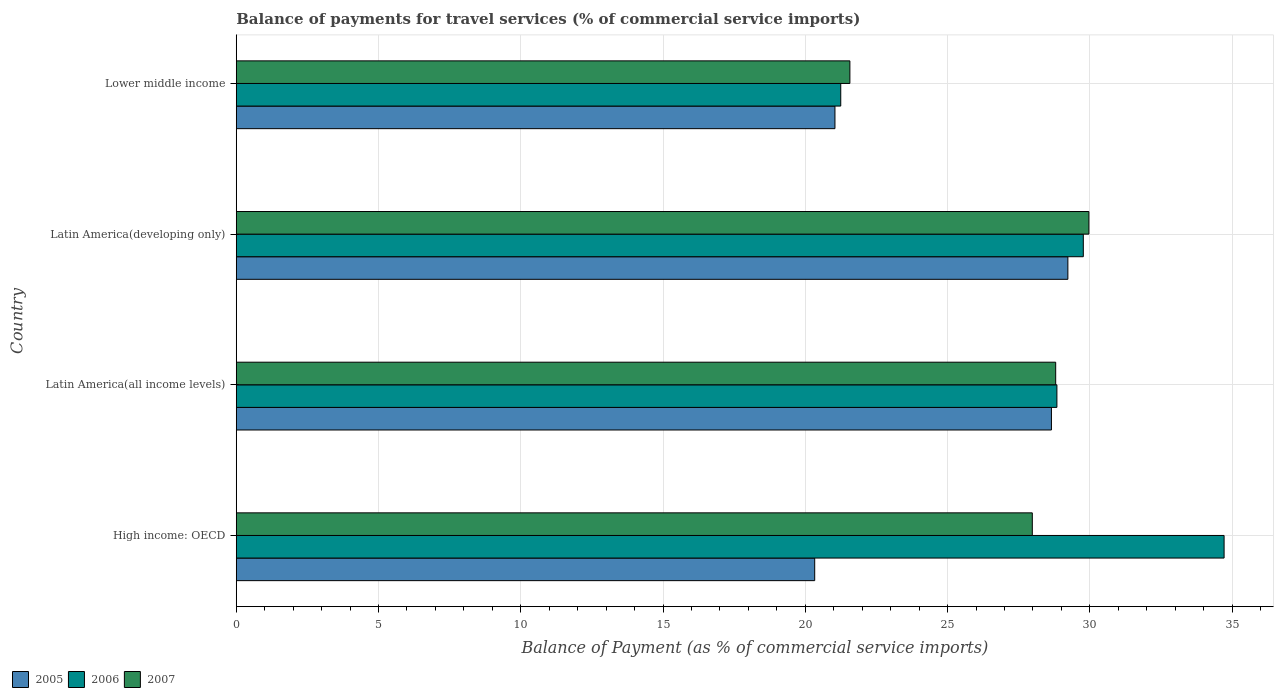Are the number of bars per tick equal to the number of legend labels?
Make the answer very short. Yes. What is the label of the 1st group of bars from the top?
Offer a very short reply. Lower middle income. What is the balance of payments for travel services in 2007 in Latin America(all income levels)?
Offer a terse response. 28.8. Across all countries, what is the maximum balance of payments for travel services in 2006?
Ensure brevity in your answer.  34.72. Across all countries, what is the minimum balance of payments for travel services in 2007?
Your response must be concise. 21.57. In which country was the balance of payments for travel services in 2006 maximum?
Make the answer very short. High income: OECD. In which country was the balance of payments for travel services in 2006 minimum?
Provide a short and direct response. Lower middle income. What is the total balance of payments for travel services in 2005 in the graph?
Your response must be concise. 99.25. What is the difference between the balance of payments for travel services in 2005 in Latin America(all income levels) and that in Lower middle income?
Offer a very short reply. 7.61. What is the difference between the balance of payments for travel services in 2005 in Lower middle income and the balance of payments for travel services in 2007 in High income: OECD?
Provide a short and direct response. -6.94. What is the average balance of payments for travel services in 2006 per country?
Your answer should be compact. 28.65. What is the difference between the balance of payments for travel services in 2006 and balance of payments for travel services in 2005 in Latin America(developing only)?
Provide a short and direct response. 0.54. In how many countries, is the balance of payments for travel services in 2006 greater than 29 %?
Give a very brief answer. 2. What is the ratio of the balance of payments for travel services in 2005 in Latin America(all income levels) to that in Lower middle income?
Offer a very short reply. 1.36. Is the difference between the balance of payments for travel services in 2006 in High income: OECD and Latin America(all income levels) greater than the difference between the balance of payments for travel services in 2005 in High income: OECD and Latin America(all income levels)?
Offer a terse response. Yes. What is the difference between the highest and the second highest balance of payments for travel services in 2007?
Your answer should be compact. 1.17. What is the difference between the highest and the lowest balance of payments for travel services in 2005?
Keep it short and to the point. 8.9. Is the sum of the balance of payments for travel services in 2005 in Latin America(all income levels) and Latin America(developing only) greater than the maximum balance of payments for travel services in 2006 across all countries?
Provide a succinct answer. Yes. What does the 1st bar from the top in Lower middle income represents?
Your answer should be compact. 2007. Is it the case that in every country, the sum of the balance of payments for travel services in 2006 and balance of payments for travel services in 2007 is greater than the balance of payments for travel services in 2005?
Make the answer very short. Yes. How many bars are there?
Provide a short and direct response. 12. Are all the bars in the graph horizontal?
Give a very brief answer. Yes. What is the difference between two consecutive major ticks on the X-axis?
Keep it short and to the point. 5. Are the values on the major ticks of X-axis written in scientific E-notation?
Offer a terse response. No. How many legend labels are there?
Give a very brief answer. 3. What is the title of the graph?
Your response must be concise. Balance of payments for travel services (% of commercial service imports). Does "1989" appear as one of the legend labels in the graph?
Ensure brevity in your answer.  No. What is the label or title of the X-axis?
Your answer should be compact. Balance of Payment (as % of commercial service imports). What is the Balance of Payment (as % of commercial service imports) in 2005 in High income: OECD?
Your answer should be very brief. 20.33. What is the Balance of Payment (as % of commercial service imports) in 2006 in High income: OECD?
Offer a terse response. 34.72. What is the Balance of Payment (as % of commercial service imports) of 2007 in High income: OECD?
Make the answer very short. 27.98. What is the Balance of Payment (as % of commercial service imports) in 2005 in Latin America(all income levels)?
Your answer should be very brief. 28.65. What is the Balance of Payment (as % of commercial service imports) in 2006 in Latin America(all income levels)?
Your answer should be compact. 28.84. What is the Balance of Payment (as % of commercial service imports) in 2007 in Latin America(all income levels)?
Give a very brief answer. 28.8. What is the Balance of Payment (as % of commercial service imports) in 2005 in Latin America(developing only)?
Make the answer very short. 29.23. What is the Balance of Payment (as % of commercial service imports) of 2006 in Latin America(developing only)?
Your answer should be very brief. 29.77. What is the Balance of Payment (as % of commercial service imports) of 2007 in Latin America(developing only)?
Offer a terse response. 29.97. What is the Balance of Payment (as % of commercial service imports) of 2005 in Lower middle income?
Keep it short and to the point. 21.04. What is the Balance of Payment (as % of commercial service imports) of 2006 in Lower middle income?
Provide a short and direct response. 21.25. What is the Balance of Payment (as % of commercial service imports) in 2007 in Lower middle income?
Your answer should be compact. 21.57. Across all countries, what is the maximum Balance of Payment (as % of commercial service imports) in 2005?
Offer a very short reply. 29.23. Across all countries, what is the maximum Balance of Payment (as % of commercial service imports) in 2006?
Keep it short and to the point. 34.72. Across all countries, what is the maximum Balance of Payment (as % of commercial service imports) of 2007?
Your answer should be very brief. 29.97. Across all countries, what is the minimum Balance of Payment (as % of commercial service imports) of 2005?
Ensure brevity in your answer.  20.33. Across all countries, what is the minimum Balance of Payment (as % of commercial service imports) in 2006?
Offer a very short reply. 21.25. Across all countries, what is the minimum Balance of Payment (as % of commercial service imports) of 2007?
Make the answer very short. 21.57. What is the total Balance of Payment (as % of commercial service imports) of 2005 in the graph?
Give a very brief answer. 99.25. What is the total Balance of Payment (as % of commercial service imports) of 2006 in the graph?
Your response must be concise. 114.58. What is the total Balance of Payment (as % of commercial service imports) in 2007 in the graph?
Provide a succinct answer. 108.31. What is the difference between the Balance of Payment (as % of commercial service imports) in 2005 in High income: OECD and that in Latin America(all income levels)?
Offer a very short reply. -8.32. What is the difference between the Balance of Payment (as % of commercial service imports) of 2006 in High income: OECD and that in Latin America(all income levels)?
Give a very brief answer. 5.88. What is the difference between the Balance of Payment (as % of commercial service imports) of 2007 in High income: OECD and that in Latin America(all income levels)?
Offer a very short reply. -0.82. What is the difference between the Balance of Payment (as % of commercial service imports) of 2005 in High income: OECD and that in Latin America(developing only)?
Offer a very short reply. -8.9. What is the difference between the Balance of Payment (as % of commercial service imports) of 2006 in High income: OECD and that in Latin America(developing only)?
Offer a very short reply. 4.95. What is the difference between the Balance of Payment (as % of commercial service imports) of 2007 in High income: OECD and that in Latin America(developing only)?
Keep it short and to the point. -1.99. What is the difference between the Balance of Payment (as % of commercial service imports) of 2005 in High income: OECD and that in Lower middle income?
Provide a short and direct response. -0.71. What is the difference between the Balance of Payment (as % of commercial service imports) of 2006 in High income: OECD and that in Lower middle income?
Your answer should be compact. 13.47. What is the difference between the Balance of Payment (as % of commercial service imports) of 2007 in High income: OECD and that in Lower middle income?
Offer a very short reply. 6.41. What is the difference between the Balance of Payment (as % of commercial service imports) of 2005 in Latin America(all income levels) and that in Latin America(developing only)?
Make the answer very short. -0.58. What is the difference between the Balance of Payment (as % of commercial service imports) in 2006 in Latin America(all income levels) and that in Latin America(developing only)?
Your response must be concise. -0.93. What is the difference between the Balance of Payment (as % of commercial service imports) of 2007 in Latin America(all income levels) and that in Latin America(developing only)?
Offer a terse response. -1.17. What is the difference between the Balance of Payment (as % of commercial service imports) of 2005 in Latin America(all income levels) and that in Lower middle income?
Provide a succinct answer. 7.61. What is the difference between the Balance of Payment (as % of commercial service imports) in 2006 in Latin America(all income levels) and that in Lower middle income?
Keep it short and to the point. 7.6. What is the difference between the Balance of Payment (as % of commercial service imports) in 2007 in Latin America(all income levels) and that in Lower middle income?
Offer a very short reply. 7.23. What is the difference between the Balance of Payment (as % of commercial service imports) in 2005 in Latin America(developing only) and that in Lower middle income?
Give a very brief answer. 8.19. What is the difference between the Balance of Payment (as % of commercial service imports) of 2006 in Latin America(developing only) and that in Lower middle income?
Offer a terse response. 8.53. What is the difference between the Balance of Payment (as % of commercial service imports) in 2007 in Latin America(developing only) and that in Lower middle income?
Your response must be concise. 8.4. What is the difference between the Balance of Payment (as % of commercial service imports) of 2005 in High income: OECD and the Balance of Payment (as % of commercial service imports) of 2006 in Latin America(all income levels)?
Your response must be concise. -8.51. What is the difference between the Balance of Payment (as % of commercial service imports) in 2005 in High income: OECD and the Balance of Payment (as % of commercial service imports) in 2007 in Latin America(all income levels)?
Ensure brevity in your answer.  -8.47. What is the difference between the Balance of Payment (as % of commercial service imports) of 2006 in High income: OECD and the Balance of Payment (as % of commercial service imports) of 2007 in Latin America(all income levels)?
Offer a very short reply. 5.92. What is the difference between the Balance of Payment (as % of commercial service imports) of 2005 in High income: OECD and the Balance of Payment (as % of commercial service imports) of 2006 in Latin America(developing only)?
Give a very brief answer. -9.44. What is the difference between the Balance of Payment (as % of commercial service imports) of 2005 in High income: OECD and the Balance of Payment (as % of commercial service imports) of 2007 in Latin America(developing only)?
Make the answer very short. -9.64. What is the difference between the Balance of Payment (as % of commercial service imports) in 2006 in High income: OECD and the Balance of Payment (as % of commercial service imports) in 2007 in Latin America(developing only)?
Make the answer very short. 4.75. What is the difference between the Balance of Payment (as % of commercial service imports) of 2005 in High income: OECD and the Balance of Payment (as % of commercial service imports) of 2006 in Lower middle income?
Ensure brevity in your answer.  -0.92. What is the difference between the Balance of Payment (as % of commercial service imports) of 2005 in High income: OECD and the Balance of Payment (as % of commercial service imports) of 2007 in Lower middle income?
Provide a succinct answer. -1.24. What is the difference between the Balance of Payment (as % of commercial service imports) in 2006 in High income: OECD and the Balance of Payment (as % of commercial service imports) in 2007 in Lower middle income?
Keep it short and to the point. 13.15. What is the difference between the Balance of Payment (as % of commercial service imports) of 2005 in Latin America(all income levels) and the Balance of Payment (as % of commercial service imports) of 2006 in Latin America(developing only)?
Your response must be concise. -1.12. What is the difference between the Balance of Payment (as % of commercial service imports) of 2005 in Latin America(all income levels) and the Balance of Payment (as % of commercial service imports) of 2007 in Latin America(developing only)?
Keep it short and to the point. -1.32. What is the difference between the Balance of Payment (as % of commercial service imports) of 2006 in Latin America(all income levels) and the Balance of Payment (as % of commercial service imports) of 2007 in Latin America(developing only)?
Your response must be concise. -1.12. What is the difference between the Balance of Payment (as % of commercial service imports) of 2005 in Latin America(all income levels) and the Balance of Payment (as % of commercial service imports) of 2006 in Lower middle income?
Make the answer very short. 7.4. What is the difference between the Balance of Payment (as % of commercial service imports) in 2005 in Latin America(all income levels) and the Balance of Payment (as % of commercial service imports) in 2007 in Lower middle income?
Your answer should be compact. 7.08. What is the difference between the Balance of Payment (as % of commercial service imports) of 2006 in Latin America(all income levels) and the Balance of Payment (as % of commercial service imports) of 2007 in Lower middle income?
Provide a succinct answer. 7.28. What is the difference between the Balance of Payment (as % of commercial service imports) of 2005 in Latin America(developing only) and the Balance of Payment (as % of commercial service imports) of 2006 in Lower middle income?
Your answer should be very brief. 7.98. What is the difference between the Balance of Payment (as % of commercial service imports) of 2005 in Latin America(developing only) and the Balance of Payment (as % of commercial service imports) of 2007 in Lower middle income?
Your answer should be compact. 7.66. What is the difference between the Balance of Payment (as % of commercial service imports) in 2006 in Latin America(developing only) and the Balance of Payment (as % of commercial service imports) in 2007 in Lower middle income?
Your answer should be compact. 8.2. What is the average Balance of Payment (as % of commercial service imports) of 2005 per country?
Offer a terse response. 24.81. What is the average Balance of Payment (as % of commercial service imports) in 2006 per country?
Keep it short and to the point. 28.65. What is the average Balance of Payment (as % of commercial service imports) in 2007 per country?
Ensure brevity in your answer.  27.08. What is the difference between the Balance of Payment (as % of commercial service imports) in 2005 and Balance of Payment (as % of commercial service imports) in 2006 in High income: OECD?
Make the answer very short. -14.39. What is the difference between the Balance of Payment (as % of commercial service imports) in 2005 and Balance of Payment (as % of commercial service imports) in 2007 in High income: OECD?
Your answer should be compact. -7.65. What is the difference between the Balance of Payment (as % of commercial service imports) in 2006 and Balance of Payment (as % of commercial service imports) in 2007 in High income: OECD?
Give a very brief answer. 6.74. What is the difference between the Balance of Payment (as % of commercial service imports) of 2005 and Balance of Payment (as % of commercial service imports) of 2006 in Latin America(all income levels)?
Ensure brevity in your answer.  -0.19. What is the difference between the Balance of Payment (as % of commercial service imports) in 2005 and Balance of Payment (as % of commercial service imports) in 2007 in Latin America(all income levels)?
Offer a very short reply. -0.15. What is the difference between the Balance of Payment (as % of commercial service imports) of 2006 and Balance of Payment (as % of commercial service imports) of 2007 in Latin America(all income levels)?
Keep it short and to the point. 0.04. What is the difference between the Balance of Payment (as % of commercial service imports) in 2005 and Balance of Payment (as % of commercial service imports) in 2006 in Latin America(developing only)?
Provide a short and direct response. -0.54. What is the difference between the Balance of Payment (as % of commercial service imports) in 2005 and Balance of Payment (as % of commercial service imports) in 2007 in Latin America(developing only)?
Ensure brevity in your answer.  -0.74. What is the difference between the Balance of Payment (as % of commercial service imports) in 2006 and Balance of Payment (as % of commercial service imports) in 2007 in Latin America(developing only)?
Give a very brief answer. -0.2. What is the difference between the Balance of Payment (as % of commercial service imports) of 2005 and Balance of Payment (as % of commercial service imports) of 2006 in Lower middle income?
Your answer should be very brief. -0.2. What is the difference between the Balance of Payment (as % of commercial service imports) in 2005 and Balance of Payment (as % of commercial service imports) in 2007 in Lower middle income?
Offer a very short reply. -0.53. What is the difference between the Balance of Payment (as % of commercial service imports) in 2006 and Balance of Payment (as % of commercial service imports) in 2007 in Lower middle income?
Offer a very short reply. -0.32. What is the ratio of the Balance of Payment (as % of commercial service imports) of 2005 in High income: OECD to that in Latin America(all income levels)?
Your response must be concise. 0.71. What is the ratio of the Balance of Payment (as % of commercial service imports) in 2006 in High income: OECD to that in Latin America(all income levels)?
Your response must be concise. 1.2. What is the ratio of the Balance of Payment (as % of commercial service imports) in 2007 in High income: OECD to that in Latin America(all income levels)?
Ensure brevity in your answer.  0.97. What is the ratio of the Balance of Payment (as % of commercial service imports) in 2005 in High income: OECD to that in Latin America(developing only)?
Offer a very short reply. 0.7. What is the ratio of the Balance of Payment (as % of commercial service imports) in 2006 in High income: OECD to that in Latin America(developing only)?
Make the answer very short. 1.17. What is the ratio of the Balance of Payment (as % of commercial service imports) in 2007 in High income: OECD to that in Latin America(developing only)?
Keep it short and to the point. 0.93. What is the ratio of the Balance of Payment (as % of commercial service imports) of 2005 in High income: OECD to that in Lower middle income?
Provide a short and direct response. 0.97. What is the ratio of the Balance of Payment (as % of commercial service imports) of 2006 in High income: OECD to that in Lower middle income?
Make the answer very short. 1.63. What is the ratio of the Balance of Payment (as % of commercial service imports) of 2007 in High income: OECD to that in Lower middle income?
Keep it short and to the point. 1.3. What is the ratio of the Balance of Payment (as % of commercial service imports) of 2005 in Latin America(all income levels) to that in Latin America(developing only)?
Make the answer very short. 0.98. What is the ratio of the Balance of Payment (as % of commercial service imports) of 2006 in Latin America(all income levels) to that in Latin America(developing only)?
Give a very brief answer. 0.97. What is the ratio of the Balance of Payment (as % of commercial service imports) of 2007 in Latin America(all income levels) to that in Latin America(developing only)?
Your answer should be very brief. 0.96. What is the ratio of the Balance of Payment (as % of commercial service imports) of 2005 in Latin America(all income levels) to that in Lower middle income?
Keep it short and to the point. 1.36. What is the ratio of the Balance of Payment (as % of commercial service imports) of 2006 in Latin America(all income levels) to that in Lower middle income?
Ensure brevity in your answer.  1.36. What is the ratio of the Balance of Payment (as % of commercial service imports) of 2007 in Latin America(all income levels) to that in Lower middle income?
Make the answer very short. 1.34. What is the ratio of the Balance of Payment (as % of commercial service imports) in 2005 in Latin America(developing only) to that in Lower middle income?
Keep it short and to the point. 1.39. What is the ratio of the Balance of Payment (as % of commercial service imports) in 2006 in Latin America(developing only) to that in Lower middle income?
Provide a short and direct response. 1.4. What is the ratio of the Balance of Payment (as % of commercial service imports) in 2007 in Latin America(developing only) to that in Lower middle income?
Give a very brief answer. 1.39. What is the difference between the highest and the second highest Balance of Payment (as % of commercial service imports) of 2005?
Give a very brief answer. 0.58. What is the difference between the highest and the second highest Balance of Payment (as % of commercial service imports) of 2006?
Provide a short and direct response. 4.95. What is the difference between the highest and the second highest Balance of Payment (as % of commercial service imports) in 2007?
Your response must be concise. 1.17. What is the difference between the highest and the lowest Balance of Payment (as % of commercial service imports) of 2005?
Keep it short and to the point. 8.9. What is the difference between the highest and the lowest Balance of Payment (as % of commercial service imports) of 2006?
Provide a succinct answer. 13.47. What is the difference between the highest and the lowest Balance of Payment (as % of commercial service imports) in 2007?
Provide a short and direct response. 8.4. 